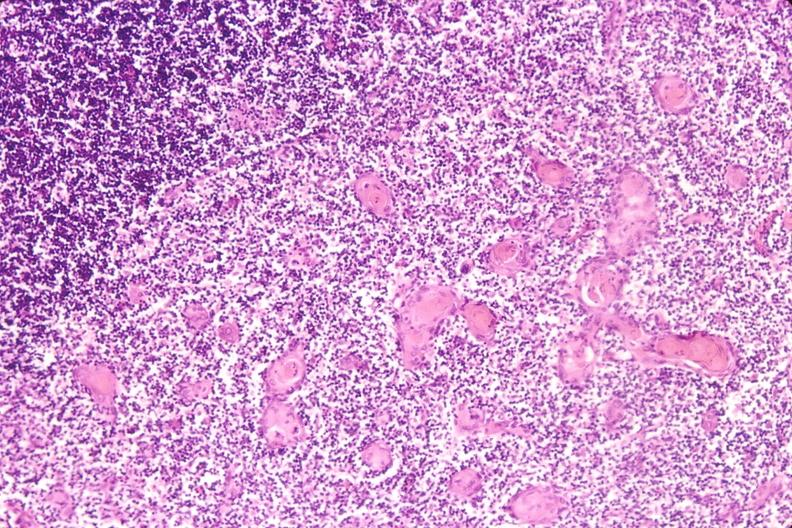what do stress induce?
Answer the question using a single word or phrase. Involution in baby with hyaline membrane disease 